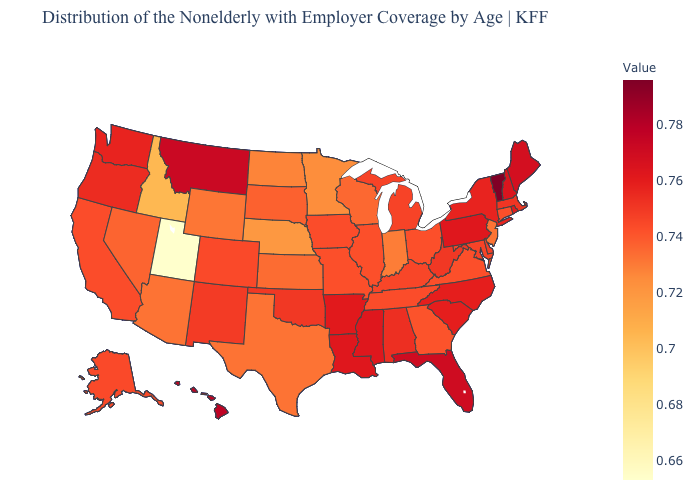Which states have the highest value in the USA?
Be succinct. Vermont. Which states hav the highest value in the South?
Be succinct. Florida. Among the states that border Ohio , does Pennsylvania have the highest value?
Concise answer only. Yes. Is the legend a continuous bar?
Short answer required. Yes. Which states hav the highest value in the South?
Write a very short answer. Florida. Which states have the highest value in the USA?
Write a very short answer. Vermont. Which states have the highest value in the USA?
Answer briefly. Vermont. 